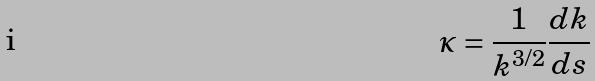<formula> <loc_0><loc_0><loc_500><loc_500>\kappa = \frac { 1 } { k ^ { 3 / 2 } } \frac { d k } { d s }</formula> 